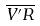Convert formula to latex. <formula><loc_0><loc_0><loc_500><loc_500>\overline { V ^ { \prime } R }</formula> 